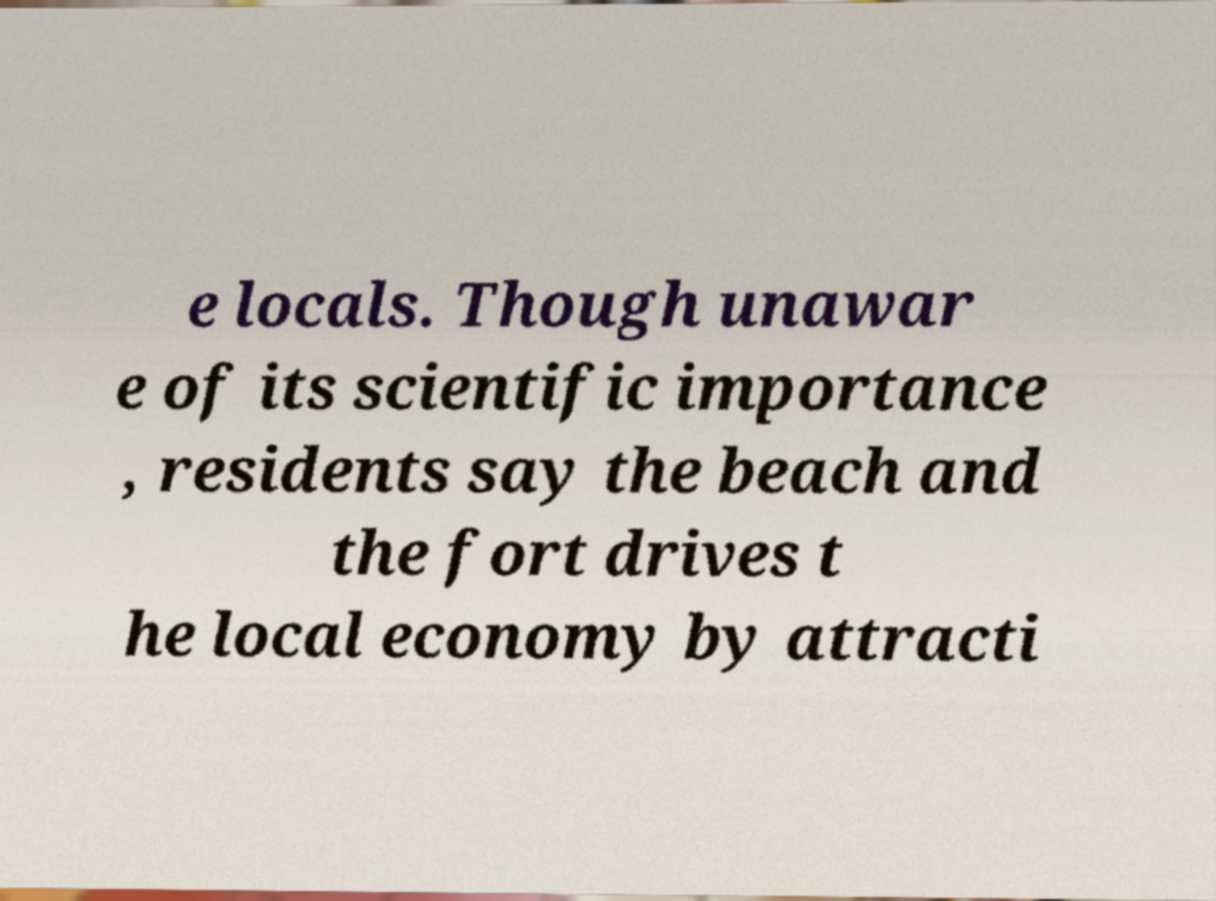Please identify and transcribe the text found in this image. e locals. Though unawar e of its scientific importance , residents say the beach and the fort drives t he local economy by attracti 